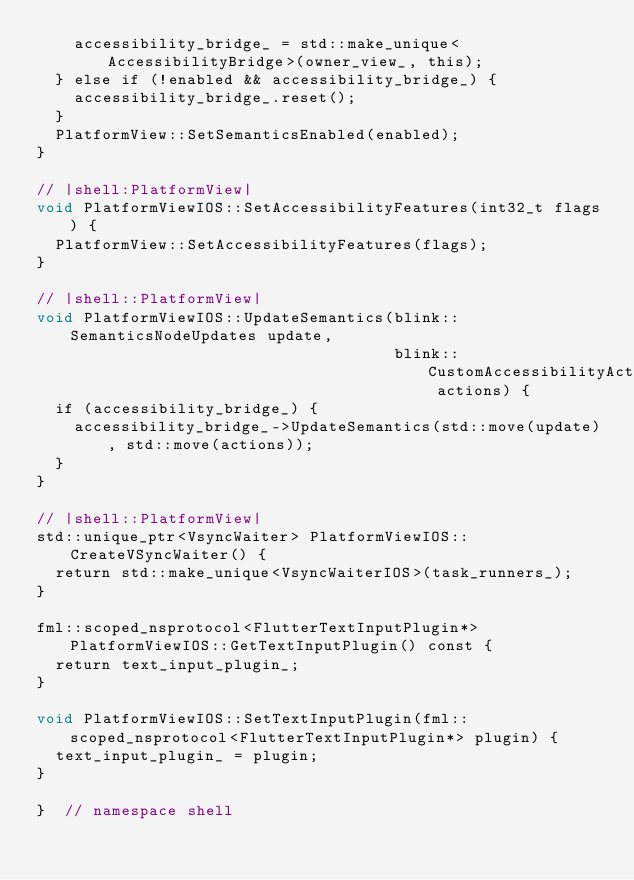Convert code to text. <code><loc_0><loc_0><loc_500><loc_500><_ObjectiveC_>    accessibility_bridge_ = std::make_unique<AccessibilityBridge>(owner_view_, this);
  } else if (!enabled && accessibility_bridge_) {
    accessibility_bridge_.reset();
  }
  PlatformView::SetSemanticsEnabled(enabled);
}

// |shell:PlatformView|
void PlatformViewIOS::SetAccessibilityFeatures(int32_t flags) {
  PlatformView::SetAccessibilityFeatures(flags);
}

// |shell::PlatformView|
void PlatformViewIOS::UpdateSemantics(blink::SemanticsNodeUpdates update,
                                      blink::CustomAccessibilityActionUpdates actions) {
  if (accessibility_bridge_) {
    accessibility_bridge_->UpdateSemantics(std::move(update), std::move(actions));
  }
}

// |shell::PlatformView|
std::unique_ptr<VsyncWaiter> PlatformViewIOS::CreateVSyncWaiter() {
  return std::make_unique<VsyncWaiterIOS>(task_runners_);
}

fml::scoped_nsprotocol<FlutterTextInputPlugin*> PlatformViewIOS::GetTextInputPlugin() const {
  return text_input_plugin_;
}

void PlatformViewIOS::SetTextInputPlugin(fml::scoped_nsprotocol<FlutterTextInputPlugin*> plugin) {
  text_input_plugin_ = plugin;
}

}  // namespace shell
</code> 